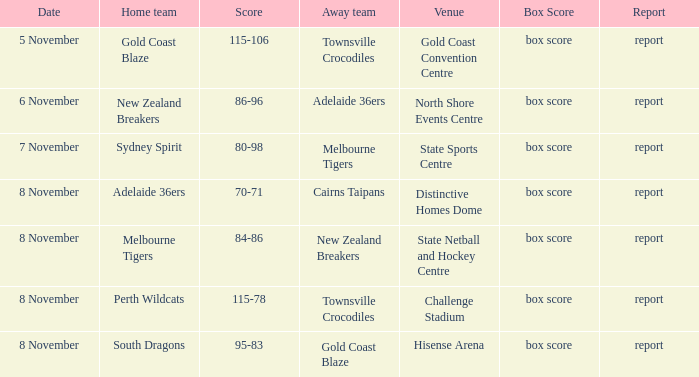What was the report at State Sports Centre? Report. Would you mind parsing the complete table? {'header': ['Date', 'Home team', 'Score', 'Away team', 'Venue', 'Box Score', 'Report'], 'rows': [['5 November', 'Gold Coast Blaze', '115-106', 'Townsville Crocodiles', 'Gold Coast Convention Centre', 'box score', 'report'], ['6 November', 'New Zealand Breakers', '86-96', 'Adelaide 36ers', 'North Shore Events Centre', 'box score', 'report'], ['7 November', 'Sydney Spirit', '80-98', 'Melbourne Tigers', 'State Sports Centre', 'box score', 'report'], ['8 November', 'Adelaide 36ers', '70-71', 'Cairns Taipans', 'Distinctive Homes Dome', 'box score', 'report'], ['8 November', 'Melbourne Tigers', '84-86', 'New Zealand Breakers', 'State Netball and Hockey Centre', 'box score', 'report'], ['8 November', 'Perth Wildcats', '115-78', 'Townsville Crocodiles', 'Challenge Stadium', 'box score', 'report'], ['8 November', 'South Dragons', '95-83', 'Gold Coast Blaze', 'Hisense Arena', 'box score', 'report']]} 